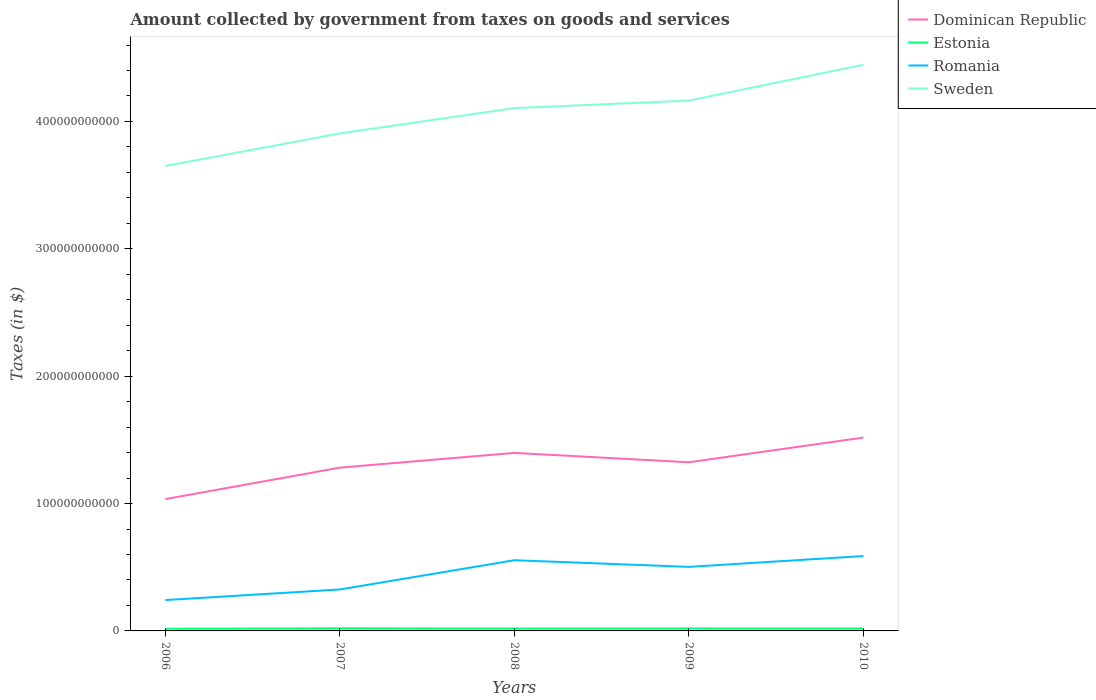Does the line corresponding to Sweden intersect with the line corresponding to Dominican Republic?
Your response must be concise. No. Across all years, what is the maximum amount collected by government from taxes on goods and services in Estonia?
Your answer should be very brief. 1.72e+09. What is the total amount collected by government from taxes on goods and services in Dominican Republic in the graph?
Your response must be concise. -4.83e+1. What is the difference between the highest and the second highest amount collected by government from taxes on goods and services in Romania?
Offer a very short reply. 3.45e+1. What is the difference between the highest and the lowest amount collected by government from taxes on goods and services in Sweden?
Ensure brevity in your answer.  3. Is the amount collected by government from taxes on goods and services in Estonia strictly greater than the amount collected by government from taxes on goods and services in Romania over the years?
Your response must be concise. Yes. How many lines are there?
Ensure brevity in your answer.  4. How many years are there in the graph?
Give a very brief answer. 5. What is the difference between two consecutive major ticks on the Y-axis?
Make the answer very short. 1.00e+11. Are the values on the major ticks of Y-axis written in scientific E-notation?
Offer a terse response. No. How are the legend labels stacked?
Make the answer very short. Vertical. What is the title of the graph?
Offer a very short reply. Amount collected by government from taxes on goods and services. What is the label or title of the Y-axis?
Offer a terse response. Taxes (in $). What is the Taxes (in $) in Dominican Republic in 2006?
Ensure brevity in your answer.  1.04e+11. What is the Taxes (in $) of Estonia in 2006?
Offer a very short reply. 1.72e+09. What is the Taxes (in $) in Romania in 2006?
Offer a terse response. 2.42e+1. What is the Taxes (in $) in Sweden in 2006?
Your answer should be very brief. 3.65e+11. What is the Taxes (in $) in Dominican Republic in 2007?
Ensure brevity in your answer.  1.28e+11. What is the Taxes (in $) in Estonia in 2007?
Your answer should be compact. 2.06e+09. What is the Taxes (in $) in Romania in 2007?
Your answer should be very brief. 3.25e+1. What is the Taxes (in $) of Sweden in 2007?
Your answer should be very brief. 3.91e+11. What is the Taxes (in $) of Dominican Republic in 2008?
Keep it short and to the point. 1.40e+11. What is the Taxes (in $) of Estonia in 2008?
Offer a very short reply. 1.89e+09. What is the Taxes (in $) of Romania in 2008?
Your response must be concise. 5.55e+1. What is the Taxes (in $) of Sweden in 2008?
Make the answer very short. 4.10e+11. What is the Taxes (in $) in Dominican Republic in 2009?
Make the answer very short. 1.32e+11. What is the Taxes (in $) of Estonia in 2009?
Ensure brevity in your answer.  1.97e+09. What is the Taxes (in $) in Romania in 2009?
Give a very brief answer. 5.03e+1. What is the Taxes (in $) of Sweden in 2009?
Your answer should be compact. 4.16e+11. What is the Taxes (in $) in Dominican Republic in 2010?
Provide a succinct answer. 1.52e+11. What is the Taxes (in $) in Estonia in 2010?
Keep it short and to the point. 1.92e+09. What is the Taxes (in $) in Romania in 2010?
Provide a succinct answer. 5.88e+1. What is the Taxes (in $) of Sweden in 2010?
Offer a very short reply. 4.45e+11. Across all years, what is the maximum Taxes (in $) of Dominican Republic?
Provide a short and direct response. 1.52e+11. Across all years, what is the maximum Taxes (in $) of Estonia?
Give a very brief answer. 2.06e+09. Across all years, what is the maximum Taxes (in $) of Romania?
Your response must be concise. 5.88e+1. Across all years, what is the maximum Taxes (in $) of Sweden?
Your answer should be compact. 4.45e+11. Across all years, what is the minimum Taxes (in $) in Dominican Republic?
Offer a very short reply. 1.04e+11. Across all years, what is the minimum Taxes (in $) of Estonia?
Offer a very short reply. 1.72e+09. Across all years, what is the minimum Taxes (in $) of Romania?
Give a very brief answer. 2.42e+1. Across all years, what is the minimum Taxes (in $) in Sweden?
Provide a short and direct response. 3.65e+11. What is the total Taxes (in $) of Dominican Republic in the graph?
Make the answer very short. 6.56e+11. What is the total Taxes (in $) in Estonia in the graph?
Provide a short and direct response. 9.56e+09. What is the total Taxes (in $) in Romania in the graph?
Give a very brief answer. 2.21e+11. What is the total Taxes (in $) of Sweden in the graph?
Give a very brief answer. 2.03e+12. What is the difference between the Taxes (in $) of Dominican Republic in 2006 and that in 2007?
Your answer should be very brief. -2.47e+1. What is the difference between the Taxes (in $) of Estonia in 2006 and that in 2007?
Give a very brief answer. -3.43e+08. What is the difference between the Taxes (in $) of Romania in 2006 and that in 2007?
Your answer should be very brief. -8.31e+09. What is the difference between the Taxes (in $) of Sweden in 2006 and that in 2007?
Provide a succinct answer. -2.55e+1. What is the difference between the Taxes (in $) of Dominican Republic in 2006 and that in 2008?
Provide a succinct answer. -3.62e+1. What is the difference between the Taxes (in $) in Estonia in 2006 and that in 2008?
Give a very brief answer. -1.66e+08. What is the difference between the Taxes (in $) in Romania in 2006 and that in 2008?
Give a very brief answer. -3.13e+1. What is the difference between the Taxes (in $) in Sweden in 2006 and that in 2008?
Your answer should be very brief. -4.54e+1. What is the difference between the Taxes (in $) of Dominican Republic in 2006 and that in 2009?
Ensure brevity in your answer.  -2.89e+1. What is the difference between the Taxes (in $) of Estonia in 2006 and that in 2009?
Give a very brief answer. -2.48e+08. What is the difference between the Taxes (in $) in Romania in 2006 and that in 2009?
Your answer should be very brief. -2.60e+1. What is the difference between the Taxes (in $) of Sweden in 2006 and that in 2009?
Ensure brevity in your answer.  -5.13e+1. What is the difference between the Taxes (in $) in Dominican Republic in 2006 and that in 2010?
Your response must be concise. -4.83e+1. What is the difference between the Taxes (in $) in Estonia in 2006 and that in 2010?
Offer a very short reply. -2.01e+08. What is the difference between the Taxes (in $) in Romania in 2006 and that in 2010?
Give a very brief answer. -3.45e+1. What is the difference between the Taxes (in $) of Sweden in 2006 and that in 2010?
Make the answer very short. -7.94e+1. What is the difference between the Taxes (in $) in Dominican Republic in 2007 and that in 2008?
Your answer should be very brief. -1.16e+1. What is the difference between the Taxes (in $) in Estonia in 2007 and that in 2008?
Offer a very short reply. 1.78e+08. What is the difference between the Taxes (in $) of Romania in 2007 and that in 2008?
Offer a very short reply. -2.30e+1. What is the difference between the Taxes (in $) in Sweden in 2007 and that in 2008?
Offer a terse response. -1.99e+1. What is the difference between the Taxes (in $) in Dominican Republic in 2007 and that in 2009?
Your answer should be very brief. -4.20e+09. What is the difference between the Taxes (in $) in Estonia in 2007 and that in 2009?
Give a very brief answer. 9.49e+07. What is the difference between the Taxes (in $) in Romania in 2007 and that in 2009?
Provide a short and direct response. -1.77e+1. What is the difference between the Taxes (in $) in Sweden in 2007 and that in 2009?
Make the answer very short. -2.58e+1. What is the difference between the Taxes (in $) in Dominican Republic in 2007 and that in 2010?
Provide a short and direct response. -2.36e+1. What is the difference between the Taxes (in $) of Estonia in 2007 and that in 2010?
Offer a terse response. 1.42e+08. What is the difference between the Taxes (in $) in Romania in 2007 and that in 2010?
Give a very brief answer. -2.62e+1. What is the difference between the Taxes (in $) in Sweden in 2007 and that in 2010?
Your response must be concise. -5.39e+1. What is the difference between the Taxes (in $) of Dominican Republic in 2008 and that in 2009?
Provide a succinct answer. 7.36e+09. What is the difference between the Taxes (in $) in Estonia in 2008 and that in 2009?
Give a very brief answer. -8.28e+07. What is the difference between the Taxes (in $) of Romania in 2008 and that in 2009?
Provide a succinct answer. 5.23e+09. What is the difference between the Taxes (in $) of Sweden in 2008 and that in 2009?
Your answer should be very brief. -5.91e+09. What is the difference between the Taxes (in $) of Dominican Republic in 2008 and that in 2010?
Your answer should be very brief. -1.20e+1. What is the difference between the Taxes (in $) of Estonia in 2008 and that in 2010?
Keep it short and to the point. -3.55e+07. What is the difference between the Taxes (in $) of Romania in 2008 and that in 2010?
Provide a short and direct response. -3.26e+09. What is the difference between the Taxes (in $) in Sweden in 2008 and that in 2010?
Your answer should be very brief. -3.40e+1. What is the difference between the Taxes (in $) of Dominican Republic in 2009 and that in 2010?
Offer a terse response. -1.94e+1. What is the difference between the Taxes (in $) in Estonia in 2009 and that in 2010?
Your answer should be compact. 4.73e+07. What is the difference between the Taxes (in $) of Romania in 2009 and that in 2010?
Give a very brief answer. -8.49e+09. What is the difference between the Taxes (in $) of Sweden in 2009 and that in 2010?
Provide a short and direct response. -2.81e+1. What is the difference between the Taxes (in $) in Dominican Republic in 2006 and the Taxes (in $) in Estonia in 2007?
Your answer should be compact. 1.01e+11. What is the difference between the Taxes (in $) of Dominican Republic in 2006 and the Taxes (in $) of Romania in 2007?
Make the answer very short. 7.10e+1. What is the difference between the Taxes (in $) in Dominican Republic in 2006 and the Taxes (in $) in Sweden in 2007?
Your answer should be very brief. -2.87e+11. What is the difference between the Taxes (in $) in Estonia in 2006 and the Taxes (in $) in Romania in 2007?
Give a very brief answer. -3.08e+1. What is the difference between the Taxes (in $) in Estonia in 2006 and the Taxes (in $) in Sweden in 2007?
Offer a terse response. -3.89e+11. What is the difference between the Taxes (in $) in Romania in 2006 and the Taxes (in $) in Sweden in 2007?
Keep it short and to the point. -3.66e+11. What is the difference between the Taxes (in $) of Dominican Republic in 2006 and the Taxes (in $) of Estonia in 2008?
Your answer should be compact. 1.02e+11. What is the difference between the Taxes (in $) of Dominican Republic in 2006 and the Taxes (in $) of Romania in 2008?
Provide a short and direct response. 4.80e+1. What is the difference between the Taxes (in $) in Dominican Republic in 2006 and the Taxes (in $) in Sweden in 2008?
Your response must be concise. -3.07e+11. What is the difference between the Taxes (in $) of Estonia in 2006 and the Taxes (in $) of Romania in 2008?
Offer a terse response. -5.38e+1. What is the difference between the Taxes (in $) in Estonia in 2006 and the Taxes (in $) in Sweden in 2008?
Ensure brevity in your answer.  -4.09e+11. What is the difference between the Taxes (in $) of Romania in 2006 and the Taxes (in $) of Sweden in 2008?
Give a very brief answer. -3.86e+11. What is the difference between the Taxes (in $) of Dominican Republic in 2006 and the Taxes (in $) of Estonia in 2009?
Provide a short and direct response. 1.02e+11. What is the difference between the Taxes (in $) of Dominican Republic in 2006 and the Taxes (in $) of Romania in 2009?
Keep it short and to the point. 5.32e+1. What is the difference between the Taxes (in $) in Dominican Republic in 2006 and the Taxes (in $) in Sweden in 2009?
Offer a terse response. -3.13e+11. What is the difference between the Taxes (in $) of Estonia in 2006 and the Taxes (in $) of Romania in 2009?
Provide a succinct answer. -4.86e+1. What is the difference between the Taxes (in $) in Estonia in 2006 and the Taxes (in $) in Sweden in 2009?
Your response must be concise. -4.15e+11. What is the difference between the Taxes (in $) of Romania in 2006 and the Taxes (in $) of Sweden in 2009?
Give a very brief answer. -3.92e+11. What is the difference between the Taxes (in $) in Dominican Republic in 2006 and the Taxes (in $) in Estonia in 2010?
Provide a short and direct response. 1.02e+11. What is the difference between the Taxes (in $) in Dominican Republic in 2006 and the Taxes (in $) in Romania in 2010?
Keep it short and to the point. 4.47e+1. What is the difference between the Taxes (in $) of Dominican Republic in 2006 and the Taxes (in $) of Sweden in 2010?
Give a very brief answer. -3.41e+11. What is the difference between the Taxes (in $) of Estonia in 2006 and the Taxes (in $) of Romania in 2010?
Provide a short and direct response. -5.71e+1. What is the difference between the Taxes (in $) of Estonia in 2006 and the Taxes (in $) of Sweden in 2010?
Provide a short and direct response. -4.43e+11. What is the difference between the Taxes (in $) in Romania in 2006 and the Taxes (in $) in Sweden in 2010?
Ensure brevity in your answer.  -4.20e+11. What is the difference between the Taxes (in $) of Dominican Republic in 2007 and the Taxes (in $) of Estonia in 2008?
Provide a short and direct response. 1.26e+11. What is the difference between the Taxes (in $) of Dominican Republic in 2007 and the Taxes (in $) of Romania in 2008?
Offer a very short reply. 7.27e+1. What is the difference between the Taxes (in $) in Dominican Republic in 2007 and the Taxes (in $) in Sweden in 2008?
Your response must be concise. -2.82e+11. What is the difference between the Taxes (in $) of Estonia in 2007 and the Taxes (in $) of Romania in 2008?
Offer a very short reply. -5.34e+1. What is the difference between the Taxes (in $) of Estonia in 2007 and the Taxes (in $) of Sweden in 2008?
Ensure brevity in your answer.  -4.08e+11. What is the difference between the Taxes (in $) of Romania in 2007 and the Taxes (in $) of Sweden in 2008?
Make the answer very short. -3.78e+11. What is the difference between the Taxes (in $) in Dominican Republic in 2007 and the Taxes (in $) in Estonia in 2009?
Offer a very short reply. 1.26e+11. What is the difference between the Taxes (in $) in Dominican Republic in 2007 and the Taxes (in $) in Romania in 2009?
Provide a succinct answer. 7.79e+1. What is the difference between the Taxes (in $) of Dominican Republic in 2007 and the Taxes (in $) of Sweden in 2009?
Give a very brief answer. -2.88e+11. What is the difference between the Taxes (in $) in Estonia in 2007 and the Taxes (in $) in Romania in 2009?
Provide a succinct answer. -4.82e+1. What is the difference between the Taxes (in $) in Estonia in 2007 and the Taxes (in $) in Sweden in 2009?
Ensure brevity in your answer.  -4.14e+11. What is the difference between the Taxes (in $) of Romania in 2007 and the Taxes (in $) of Sweden in 2009?
Give a very brief answer. -3.84e+11. What is the difference between the Taxes (in $) of Dominican Republic in 2007 and the Taxes (in $) of Estonia in 2010?
Offer a very short reply. 1.26e+11. What is the difference between the Taxes (in $) of Dominican Republic in 2007 and the Taxes (in $) of Romania in 2010?
Your response must be concise. 6.94e+1. What is the difference between the Taxes (in $) in Dominican Republic in 2007 and the Taxes (in $) in Sweden in 2010?
Offer a very short reply. -3.16e+11. What is the difference between the Taxes (in $) of Estonia in 2007 and the Taxes (in $) of Romania in 2010?
Your answer should be very brief. -5.67e+1. What is the difference between the Taxes (in $) of Estonia in 2007 and the Taxes (in $) of Sweden in 2010?
Provide a succinct answer. -4.42e+11. What is the difference between the Taxes (in $) in Romania in 2007 and the Taxes (in $) in Sweden in 2010?
Provide a succinct answer. -4.12e+11. What is the difference between the Taxes (in $) of Dominican Republic in 2008 and the Taxes (in $) of Estonia in 2009?
Give a very brief answer. 1.38e+11. What is the difference between the Taxes (in $) in Dominican Republic in 2008 and the Taxes (in $) in Romania in 2009?
Your answer should be very brief. 8.95e+1. What is the difference between the Taxes (in $) of Dominican Republic in 2008 and the Taxes (in $) of Sweden in 2009?
Provide a short and direct response. -2.77e+11. What is the difference between the Taxes (in $) in Estonia in 2008 and the Taxes (in $) in Romania in 2009?
Ensure brevity in your answer.  -4.84e+1. What is the difference between the Taxes (in $) in Estonia in 2008 and the Taxes (in $) in Sweden in 2009?
Make the answer very short. -4.15e+11. What is the difference between the Taxes (in $) of Romania in 2008 and the Taxes (in $) of Sweden in 2009?
Your response must be concise. -3.61e+11. What is the difference between the Taxes (in $) of Dominican Republic in 2008 and the Taxes (in $) of Estonia in 2010?
Your response must be concise. 1.38e+11. What is the difference between the Taxes (in $) of Dominican Republic in 2008 and the Taxes (in $) of Romania in 2010?
Give a very brief answer. 8.10e+1. What is the difference between the Taxes (in $) in Dominican Republic in 2008 and the Taxes (in $) in Sweden in 2010?
Make the answer very short. -3.05e+11. What is the difference between the Taxes (in $) of Estonia in 2008 and the Taxes (in $) of Romania in 2010?
Ensure brevity in your answer.  -5.69e+1. What is the difference between the Taxes (in $) of Estonia in 2008 and the Taxes (in $) of Sweden in 2010?
Ensure brevity in your answer.  -4.43e+11. What is the difference between the Taxes (in $) of Romania in 2008 and the Taxes (in $) of Sweden in 2010?
Keep it short and to the point. -3.89e+11. What is the difference between the Taxes (in $) of Dominican Republic in 2009 and the Taxes (in $) of Estonia in 2010?
Provide a succinct answer. 1.30e+11. What is the difference between the Taxes (in $) of Dominican Republic in 2009 and the Taxes (in $) of Romania in 2010?
Your answer should be compact. 7.36e+1. What is the difference between the Taxes (in $) of Dominican Republic in 2009 and the Taxes (in $) of Sweden in 2010?
Provide a succinct answer. -3.12e+11. What is the difference between the Taxes (in $) of Estonia in 2009 and the Taxes (in $) of Romania in 2010?
Give a very brief answer. -5.68e+1. What is the difference between the Taxes (in $) in Estonia in 2009 and the Taxes (in $) in Sweden in 2010?
Make the answer very short. -4.43e+11. What is the difference between the Taxes (in $) of Romania in 2009 and the Taxes (in $) of Sweden in 2010?
Offer a very short reply. -3.94e+11. What is the average Taxes (in $) of Dominican Republic per year?
Offer a terse response. 1.31e+11. What is the average Taxes (in $) in Estonia per year?
Your answer should be very brief. 1.91e+09. What is the average Taxes (in $) in Romania per year?
Offer a very short reply. 4.43e+1. What is the average Taxes (in $) in Sweden per year?
Ensure brevity in your answer.  4.05e+11. In the year 2006, what is the difference between the Taxes (in $) in Dominican Republic and Taxes (in $) in Estonia?
Ensure brevity in your answer.  1.02e+11. In the year 2006, what is the difference between the Taxes (in $) in Dominican Republic and Taxes (in $) in Romania?
Keep it short and to the point. 7.93e+1. In the year 2006, what is the difference between the Taxes (in $) of Dominican Republic and Taxes (in $) of Sweden?
Offer a very short reply. -2.62e+11. In the year 2006, what is the difference between the Taxes (in $) in Estonia and Taxes (in $) in Romania?
Make the answer very short. -2.25e+1. In the year 2006, what is the difference between the Taxes (in $) in Estonia and Taxes (in $) in Sweden?
Offer a very short reply. -3.63e+11. In the year 2006, what is the difference between the Taxes (in $) of Romania and Taxes (in $) of Sweden?
Your answer should be very brief. -3.41e+11. In the year 2007, what is the difference between the Taxes (in $) in Dominican Republic and Taxes (in $) in Estonia?
Ensure brevity in your answer.  1.26e+11. In the year 2007, what is the difference between the Taxes (in $) in Dominican Republic and Taxes (in $) in Romania?
Your answer should be very brief. 9.57e+1. In the year 2007, what is the difference between the Taxes (in $) of Dominican Republic and Taxes (in $) of Sweden?
Your answer should be compact. -2.62e+11. In the year 2007, what is the difference between the Taxes (in $) of Estonia and Taxes (in $) of Romania?
Provide a short and direct response. -3.05e+1. In the year 2007, what is the difference between the Taxes (in $) in Estonia and Taxes (in $) in Sweden?
Make the answer very short. -3.89e+11. In the year 2007, what is the difference between the Taxes (in $) of Romania and Taxes (in $) of Sweden?
Make the answer very short. -3.58e+11. In the year 2008, what is the difference between the Taxes (in $) in Dominican Republic and Taxes (in $) in Estonia?
Provide a succinct answer. 1.38e+11. In the year 2008, what is the difference between the Taxes (in $) in Dominican Republic and Taxes (in $) in Romania?
Ensure brevity in your answer.  8.43e+1. In the year 2008, what is the difference between the Taxes (in $) of Dominican Republic and Taxes (in $) of Sweden?
Your answer should be very brief. -2.71e+11. In the year 2008, what is the difference between the Taxes (in $) in Estonia and Taxes (in $) in Romania?
Your response must be concise. -5.36e+1. In the year 2008, what is the difference between the Taxes (in $) of Estonia and Taxes (in $) of Sweden?
Your answer should be compact. -4.09e+11. In the year 2008, what is the difference between the Taxes (in $) in Romania and Taxes (in $) in Sweden?
Your answer should be very brief. -3.55e+11. In the year 2009, what is the difference between the Taxes (in $) in Dominican Republic and Taxes (in $) in Estonia?
Offer a very short reply. 1.30e+11. In the year 2009, what is the difference between the Taxes (in $) of Dominican Republic and Taxes (in $) of Romania?
Ensure brevity in your answer.  8.21e+1. In the year 2009, what is the difference between the Taxes (in $) in Dominican Republic and Taxes (in $) in Sweden?
Offer a very short reply. -2.84e+11. In the year 2009, what is the difference between the Taxes (in $) in Estonia and Taxes (in $) in Romania?
Keep it short and to the point. -4.83e+1. In the year 2009, what is the difference between the Taxes (in $) of Estonia and Taxes (in $) of Sweden?
Keep it short and to the point. -4.14e+11. In the year 2009, what is the difference between the Taxes (in $) in Romania and Taxes (in $) in Sweden?
Ensure brevity in your answer.  -3.66e+11. In the year 2010, what is the difference between the Taxes (in $) of Dominican Republic and Taxes (in $) of Estonia?
Make the answer very short. 1.50e+11. In the year 2010, what is the difference between the Taxes (in $) of Dominican Republic and Taxes (in $) of Romania?
Provide a short and direct response. 9.30e+1. In the year 2010, what is the difference between the Taxes (in $) of Dominican Republic and Taxes (in $) of Sweden?
Offer a very short reply. -2.93e+11. In the year 2010, what is the difference between the Taxes (in $) in Estonia and Taxes (in $) in Romania?
Ensure brevity in your answer.  -5.69e+1. In the year 2010, what is the difference between the Taxes (in $) of Estonia and Taxes (in $) of Sweden?
Your answer should be very brief. -4.43e+11. In the year 2010, what is the difference between the Taxes (in $) in Romania and Taxes (in $) in Sweden?
Your answer should be very brief. -3.86e+11. What is the ratio of the Taxes (in $) of Dominican Republic in 2006 to that in 2007?
Give a very brief answer. 0.81. What is the ratio of the Taxes (in $) in Estonia in 2006 to that in 2007?
Your response must be concise. 0.83. What is the ratio of the Taxes (in $) in Romania in 2006 to that in 2007?
Provide a short and direct response. 0.74. What is the ratio of the Taxes (in $) in Sweden in 2006 to that in 2007?
Offer a terse response. 0.93. What is the ratio of the Taxes (in $) in Dominican Republic in 2006 to that in 2008?
Your answer should be very brief. 0.74. What is the ratio of the Taxes (in $) of Estonia in 2006 to that in 2008?
Offer a very short reply. 0.91. What is the ratio of the Taxes (in $) of Romania in 2006 to that in 2008?
Offer a terse response. 0.44. What is the ratio of the Taxes (in $) of Sweden in 2006 to that in 2008?
Make the answer very short. 0.89. What is the ratio of the Taxes (in $) of Dominican Republic in 2006 to that in 2009?
Your answer should be compact. 0.78. What is the ratio of the Taxes (in $) of Estonia in 2006 to that in 2009?
Ensure brevity in your answer.  0.87. What is the ratio of the Taxes (in $) of Romania in 2006 to that in 2009?
Your answer should be compact. 0.48. What is the ratio of the Taxes (in $) in Sweden in 2006 to that in 2009?
Your answer should be compact. 0.88. What is the ratio of the Taxes (in $) in Dominican Republic in 2006 to that in 2010?
Your response must be concise. 0.68. What is the ratio of the Taxes (in $) of Estonia in 2006 to that in 2010?
Your answer should be compact. 0.9. What is the ratio of the Taxes (in $) of Romania in 2006 to that in 2010?
Ensure brevity in your answer.  0.41. What is the ratio of the Taxes (in $) of Sweden in 2006 to that in 2010?
Ensure brevity in your answer.  0.82. What is the ratio of the Taxes (in $) in Dominican Republic in 2007 to that in 2008?
Offer a very short reply. 0.92. What is the ratio of the Taxes (in $) of Estonia in 2007 to that in 2008?
Make the answer very short. 1.09. What is the ratio of the Taxes (in $) in Romania in 2007 to that in 2008?
Give a very brief answer. 0.59. What is the ratio of the Taxes (in $) of Sweden in 2007 to that in 2008?
Your response must be concise. 0.95. What is the ratio of the Taxes (in $) of Dominican Republic in 2007 to that in 2009?
Make the answer very short. 0.97. What is the ratio of the Taxes (in $) of Estonia in 2007 to that in 2009?
Give a very brief answer. 1.05. What is the ratio of the Taxes (in $) of Romania in 2007 to that in 2009?
Offer a terse response. 0.65. What is the ratio of the Taxes (in $) of Sweden in 2007 to that in 2009?
Keep it short and to the point. 0.94. What is the ratio of the Taxes (in $) of Dominican Republic in 2007 to that in 2010?
Ensure brevity in your answer.  0.84. What is the ratio of the Taxes (in $) of Estonia in 2007 to that in 2010?
Ensure brevity in your answer.  1.07. What is the ratio of the Taxes (in $) of Romania in 2007 to that in 2010?
Offer a terse response. 0.55. What is the ratio of the Taxes (in $) in Sweden in 2007 to that in 2010?
Your answer should be compact. 0.88. What is the ratio of the Taxes (in $) of Dominican Republic in 2008 to that in 2009?
Give a very brief answer. 1.06. What is the ratio of the Taxes (in $) in Estonia in 2008 to that in 2009?
Make the answer very short. 0.96. What is the ratio of the Taxes (in $) of Romania in 2008 to that in 2009?
Offer a very short reply. 1.1. What is the ratio of the Taxes (in $) in Sweden in 2008 to that in 2009?
Give a very brief answer. 0.99. What is the ratio of the Taxes (in $) of Dominican Republic in 2008 to that in 2010?
Your response must be concise. 0.92. What is the ratio of the Taxes (in $) of Estonia in 2008 to that in 2010?
Make the answer very short. 0.98. What is the ratio of the Taxes (in $) in Romania in 2008 to that in 2010?
Give a very brief answer. 0.94. What is the ratio of the Taxes (in $) of Sweden in 2008 to that in 2010?
Your answer should be very brief. 0.92. What is the ratio of the Taxes (in $) of Dominican Republic in 2009 to that in 2010?
Offer a terse response. 0.87. What is the ratio of the Taxes (in $) of Estonia in 2009 to that in 2010?
Your answer should be very brief. 1.02. What is the ratio of the Taxes (in $) in Romania in 2009 to that in 2010?
Keep it short and to the point. 0.86. What is the ratio of the Taxes (in $) of Sweden in 2009 to that in 2010?
Provide a short and direct response. 0.94. What is the difference between the highest and the second highest Taxes (in $) of Dominican Republic?
Keep it short and to the point. 1.20e+1. What is the difference between the highest and the second highest Taxes (in $) in Estonia?
Give a very brief answer. 9.49e+07. What is the difference between the highest and the second highest Taxes (in $) of Romania?
Your response must be concise. 3.26e+09. What is the difference between the highest and the second highest Taxes (in $) of Sweden?
Offer a terse response. 2.81e+1. What is the difference between the highest and the lowest Taxes (in $) of Dominican Republic?
Your answer should be very brief. 4.83e+1. What is the difference between the highest and the lowest Taxes (in $) of Estonia?
Make the answer very short. 3.43e+08. What is the difference between the highest and the lowest Taxes (in $) in Romania?
Keep it short and to the point. 3.45e+1. What is the difference between the highest and the lowest Taxes (in $) of Sweden?
Provide a succinct answer. 7.94e+1. 